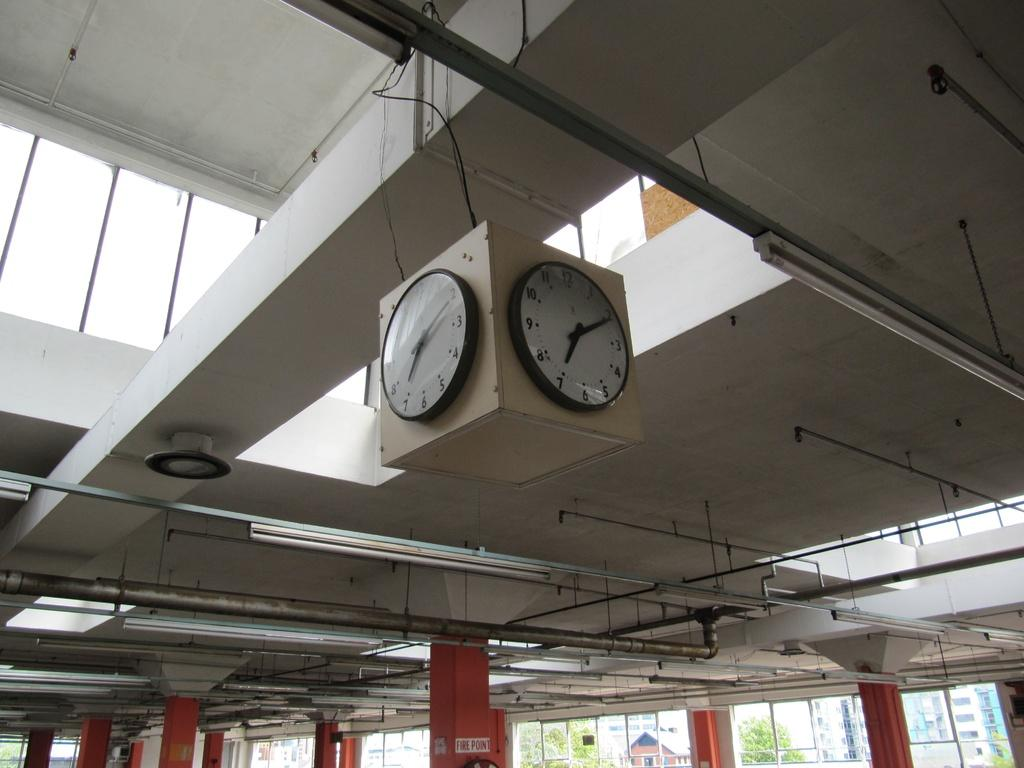Provide a one-sentence caption for the provided image. The inside of a building and two clocks near the ceiling both of which have the number 7 on them. 